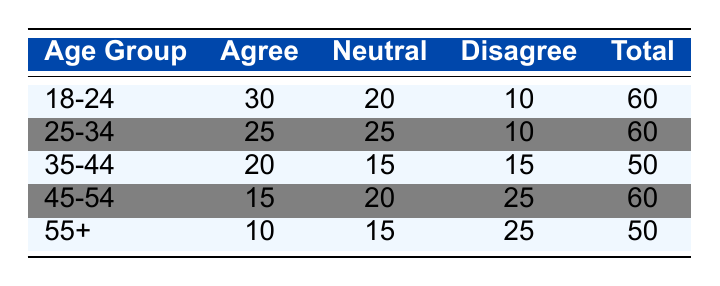What is the total frequency of respondents in the age group 18-24? The total frequency for the age group 18-24 is found by adding the frequencies of Agree (30), Neutral (20), and Disagree (10): 30 + 20 + 10 = 60.
Answer: 60 Which age group has the highest frequency of respondents who agree with emotional expression? In the table, the highest frequency of respondents who agree is in the 18-24 age group with 30, compared to other groups.
Answer: 18-24 What percentage of respondents aged 25-34 disagreed with emotional expression? To find the percentage of those who disagreed aged 25-34, take the frequency of Disagree (10) and divide it by the total for the age group (60): (10/60) * 100 = 16.67%.
Answer: 16.67% Is it true that the majority of respondents aged 55 and over disagree with emotional expression? For the age group 55+, the frequency of Disagree is 25, while Agree has 10 and Neutral has 15. Since 25 is the highest among those options, it indicates the majority disagree.
Answer: Yes What is the difference in the number of respondents who agree between the age groups 18-24 and 45-54? The Agree frequency for 18-24 is 30 and for 45-54 is 15. The difference is calculated by subtracting the frequencies: 30 - 15 = 15.
Answer: 15 What is the total number of respondents who expressed a neutral attitude across all age groups? To find this, add the Neutral frequencies from all age groups: 20 (18-24) + 25 (25-34) + 15 (35-44) + 20 (45-54) + 15 (55+) = 105.
Answer: 105 How many respondents aged 35-44 expressed a neutral or disagreeing attitude? The Neutral frequency for 35-44 is 15 and Disagree frequency is also 15. Adding these gives: 15 + 15 = 30.
Answer: 30 Which age group has the highest number of respondents expressing a neutral attitude? The age group 25-34 has the highest frequency of 25 for Neutral, which is greater than all other age groups.
Answer: 25-34 